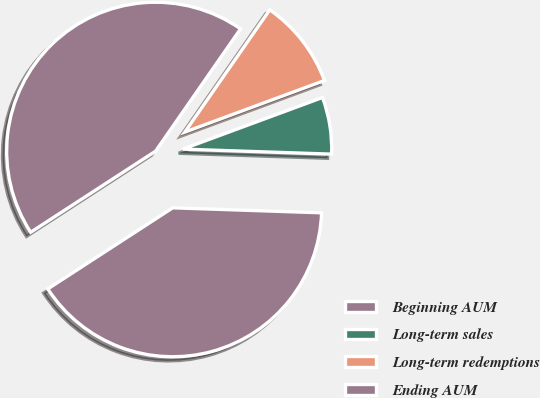Convert chart. <chart><loc_0><loc_0><loc_500><loc_500><pie_chart><fcel>Beginning AUM<fcel>Long-term sales<fcel>Long-term redemptions<fcel>Ending AUM<nl><fcel>40.3%<fcel>6.17%<fcel>9.7%<fcel>43.83%<nl></chart> 